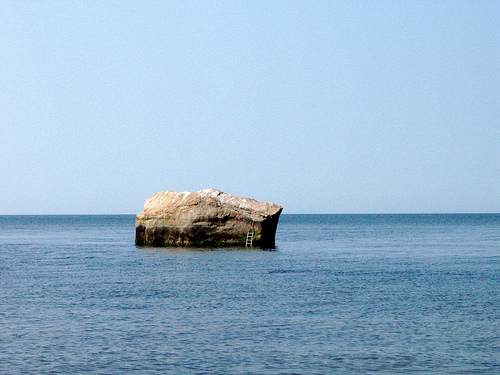<image>
Can you confirm if the rock is next to the water? No. The rock is not positioned next to the water. They are located in different areas of the scene. Is the sky above the sea? Yes. The sky is positioned above the sea in the vertical space, higher up in the scene. 